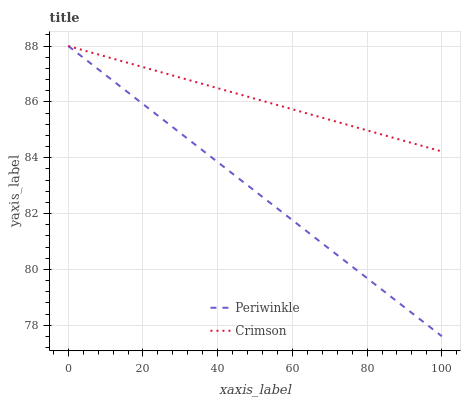Does Periwinkle have the minimum area under the curve?
Answer yes or no. Yes. Does Crimson have the maximum area under the curve?
Answer yes or no. Yes. Does Periwinkle have the maximum area under the curve?
Answer yes or no. No. Is Periwinkle the smoothest?
Answer yes or no. Yes. Is Crimson the roughest?
Answer yes or no. Yes. Is Periwinkle the roughest?
Answer yes or no. No. Does Periwinkle have the lowest value?
Answer yes or no. Yes. Does Periwinkle have the highest value?
Answer yes or no. Yes. Does Crimson intersect Periwinkle?
Answer yes or no. Yes. Is Crimson less than Periwinkle?
Answer yes or no. No. Is Crimson greater than Periwinkle?
Answer yes or no. No. 